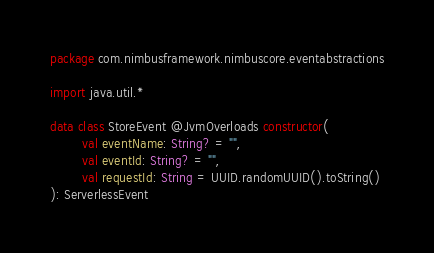Convert code to text. <code><loc_0><loc_0><loc_500><loc_500><_Kotlin_>package com.nimbusframework.nimbuscore.eventabstractions

import java.util.*

data class StoreEvent @JvmOverloads constructor(
        val eventName: String? = "",
        val eventId: String? = "",
        val requestId: String = UUID.randomUUID().toString()
): ServerlessEvent</code> 